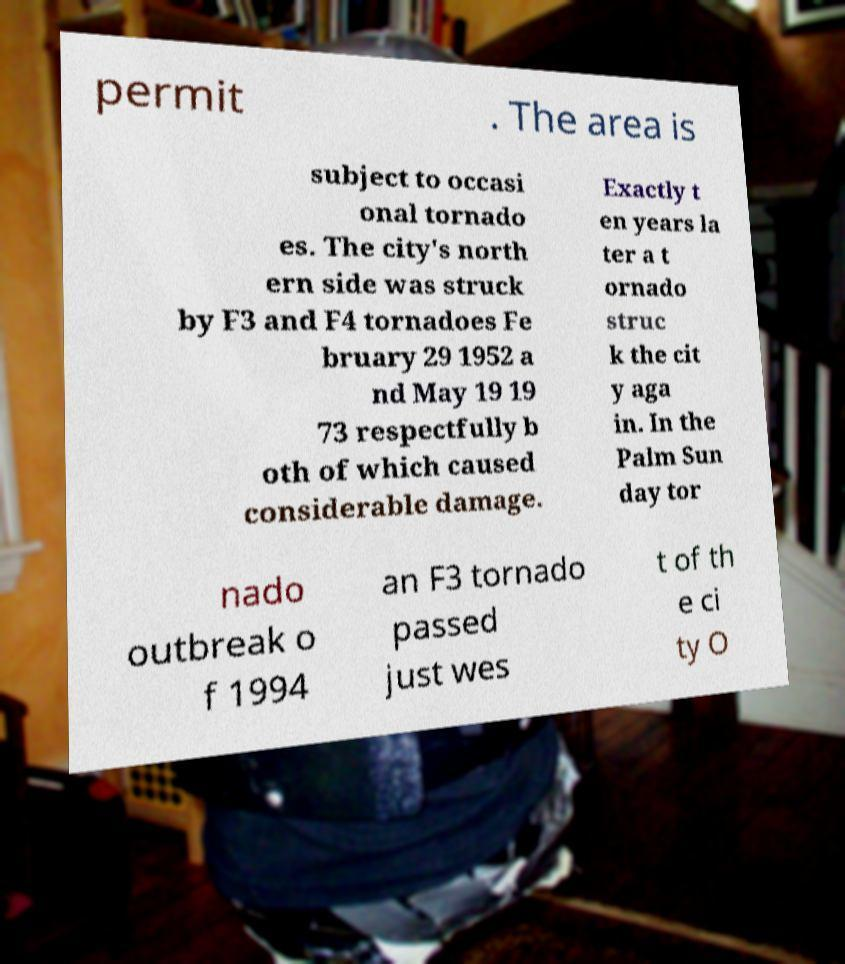Please identify and transcribe the text found in this image. permit . The area is subject to occasi onal tornado es. The city's north ern side was struck by F3 and F4 tornadoes Fe bruary 29 1952 a nd May 19 19 73 respectfully b oth of which caused considerable damage. Exactly t en years la ter a t ornado struc k the cit y aga in. In the Palm Sun day tor nado outbreak o f 1994 an F3 tornado passed just wes t of th e ci ty O 